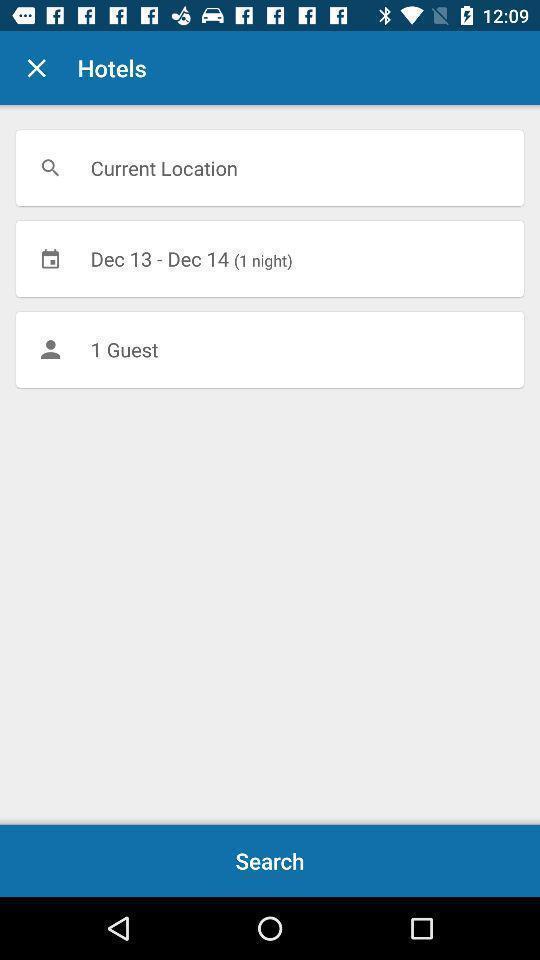Provide a detailed account of this screenshot. Search page of travel application. 